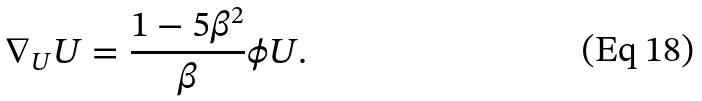<formula> <loc_0><loc_0><loc_500><loc_500>\nabla _ { U } U = \frac { 1 - 5 \beta ^ { 2 } } { \beta } \phi U .</formula> 